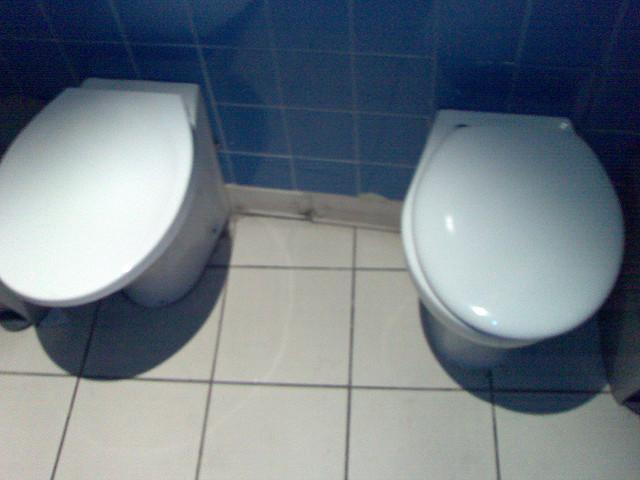What color is the walls?
Concise answer only. Blue. How many toilets are there?
Be succinct. 2. Is the seat up or down?
Be succinct. Down. 